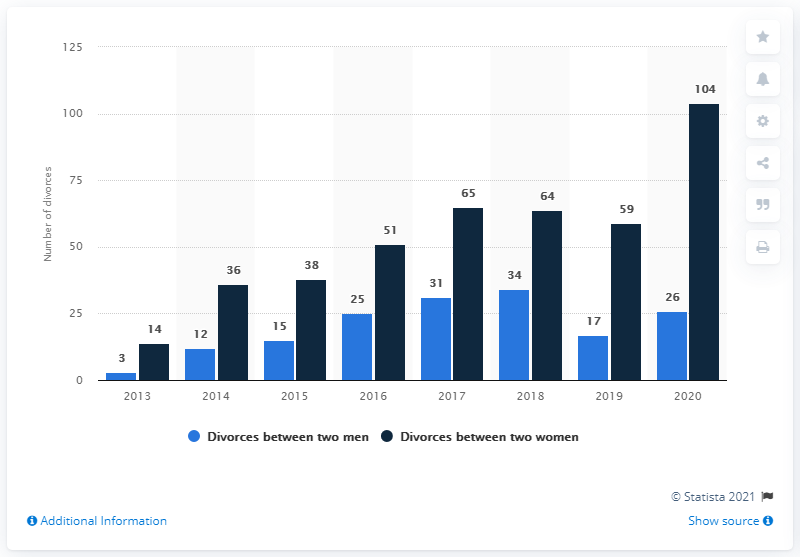Highlight a few significant elements in this photo. In 2020, 26 male couples experienced a divorce. In 2020, 104 female couples got divorced. 